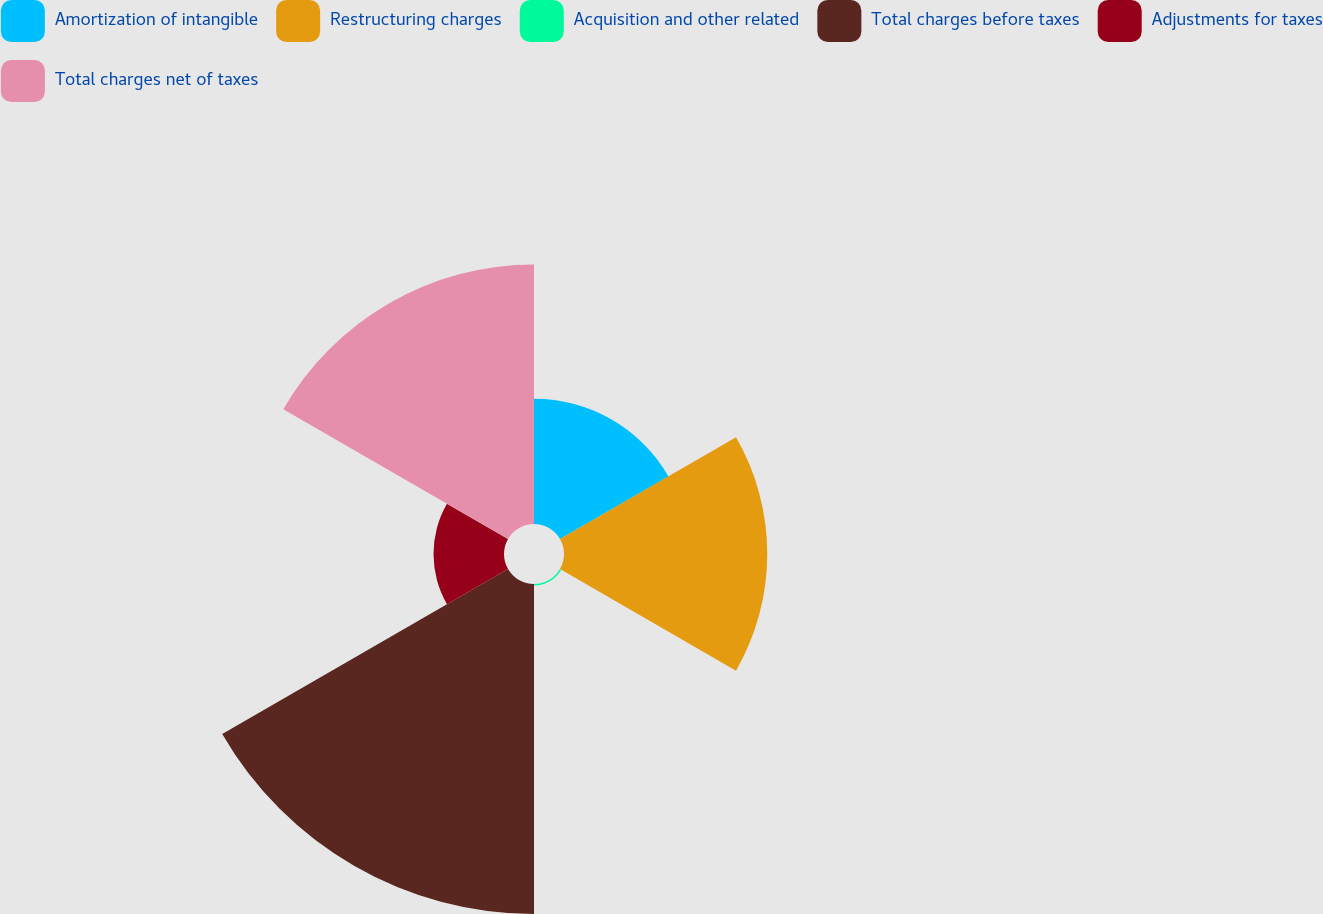<chart> <loc_0><loc_0><loc_500><loc_500><pie_chart><fcel>Amortization of intangible<fcel>Restructuring charges<fcel>Acquisition and other related<fcel>Total charges before taxes<fcel>Adjustments for taxes<fcel>Total charges net of taxes<nl><fcel>12.65%<fcel>20.53%<fcel>0.15%<fcel>33.33%<fcel>7.12%<fcel>26.21%<nl></chart> 